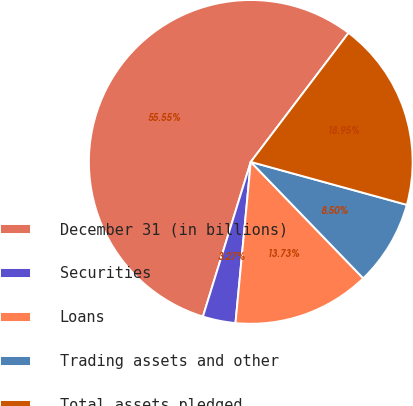<chart> <loc_0><loc_0><loc_500><loc_500><pie_chart><fcel>December 31 (in billions)<fcel>Securities<fcel>Loans<fcel>Trading assets and other<fcel>Total assets pledged<nl><fcel>55.54%<fcel>3.27%<fcel>13.73%<fcel>8.5%<fcel>18.95%<nl></chart> 